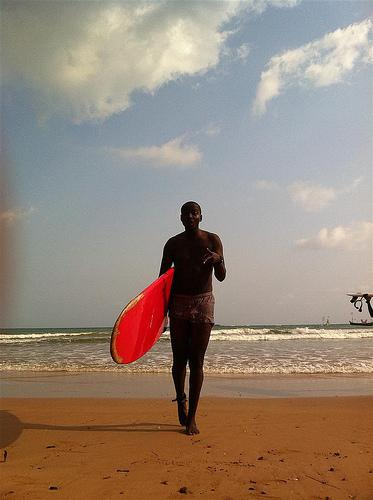Question: how many men are in the photo?
Choices:
A. 2.
B. 3.
C. 1.
D. 4.
Answer with the letter. Answer: C Question: how many women are at the beach?
Choices:
A. 1.
B. 2.
C. 0.
D. 3.
Answer with the letter. Answer: C Question: what is color is the men's board?
Choices:
A. Red.
B. Blue.
C. Green.
D. Black.
Answer with the letter. Answer: A Question: where is the under the man's arm?
Choices:
A. Towel.
B. Umbrella.
C. A surfboard.
D. Snorkel.
Answer with the letter. Answer: C Question: who is wearing shorts?
Choices:
A. The woman.
B. The child.
C. The baby.
D. The man.
Answer with the letter. Answer: D Question: what is the man walking on?
Choices:
A. Sand.
B. Gravel.
C. Grass.
D. Sidewalk.
Answer with the letter. Answer: A Question: what is the man holding?
Choices:
A. A canoe.
B. A towel.
C. A surfboard.
D. A raft.
Answer with the letter. Answer: C 